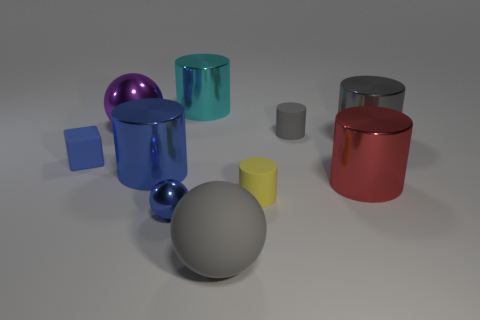Subtract all red cylinders. How many cylinders are left? 5 Subtract all yellow cylinders. How many cylinders are left? 5 Subtract 1 cylinders. How many cylinders are left? 5 Subtract all cyan cylinders. Subtract all cyan blocks. How many cylinders are left? 5 Subtract all cylinders. How many objects are left? 4 Add 3 blue things. How many blue things are left? 6 Add 8 large gray cylinders. How many large gray cylinders exist? 9 Subtract 0 green cylinders. How many objects are left? 10 Subtract all metallic cylinders. Subtract all cubes. How many objects are left? 5 